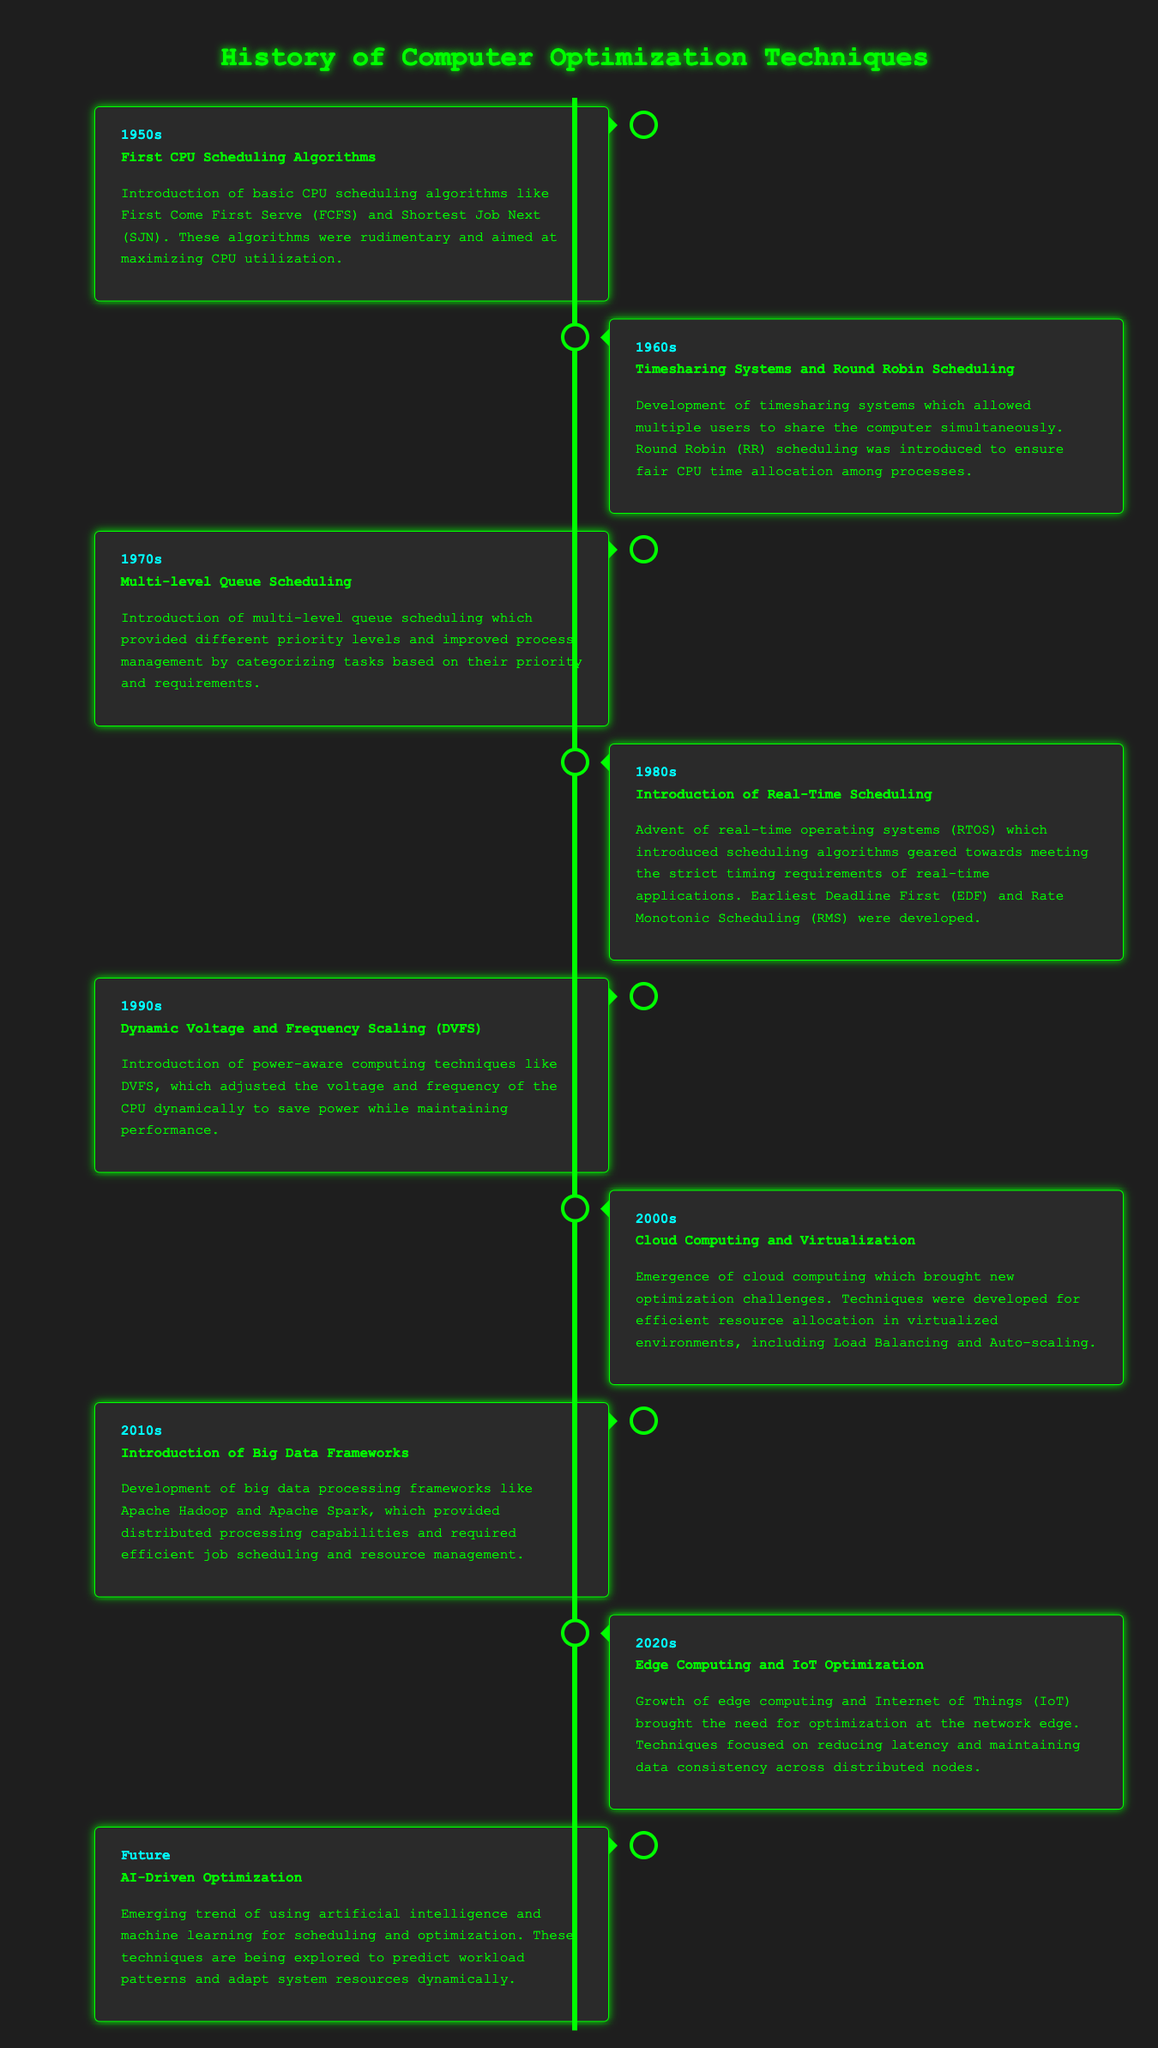what was the first CPU scheduling algorithm introduced? The first CPU scheduling algorithms introduced were First Come First Serve (FCFS) and Shortest Job Next (SJN).
Answer: First Come First Serve in which decade was the concept of real-time scheduling introduced? The introduction of real-time scheduling occurred in the 1980s, as noted in the timeline.
Answer: 1980s what significant technique was developed in the 1990s related to power management? The 1990s saw the introduction of Dynamic Voltage and Frequency Scaling (DVFS) as a power-aware computing technique.
Answer: Dynamic Voltage and Frequency Scaling how does the timeline categorize events? Events in the timeline are categorized by decades, starting from the 1950s to the future.
Answer: Decades what innovation emerged in the 2000s related to resource management? The 2000s marked the emergence of cloud computing, which brought new optimization challenges for resource management.
Answer: Cloud Computing which big data frameworks were developed in the 2010s? The frameworks that emerged in the 2010s include Apache Hadoop and Apache Spark.
Answer: Apache Hadoop and Apache Spark what is the focus of optimization techniques in the 2020s? The focus of optimization techniques in the 2020s is on edge computing and IoT optimization.
Answer: Edge Computing and IoT Optimization what upcoming trend in optimization is mentioned for the future? The future mentions the trend of AI-driven optimization techniques utilizing artificial intelligence for scheduling.
Answer: AI-Driven Optimization 